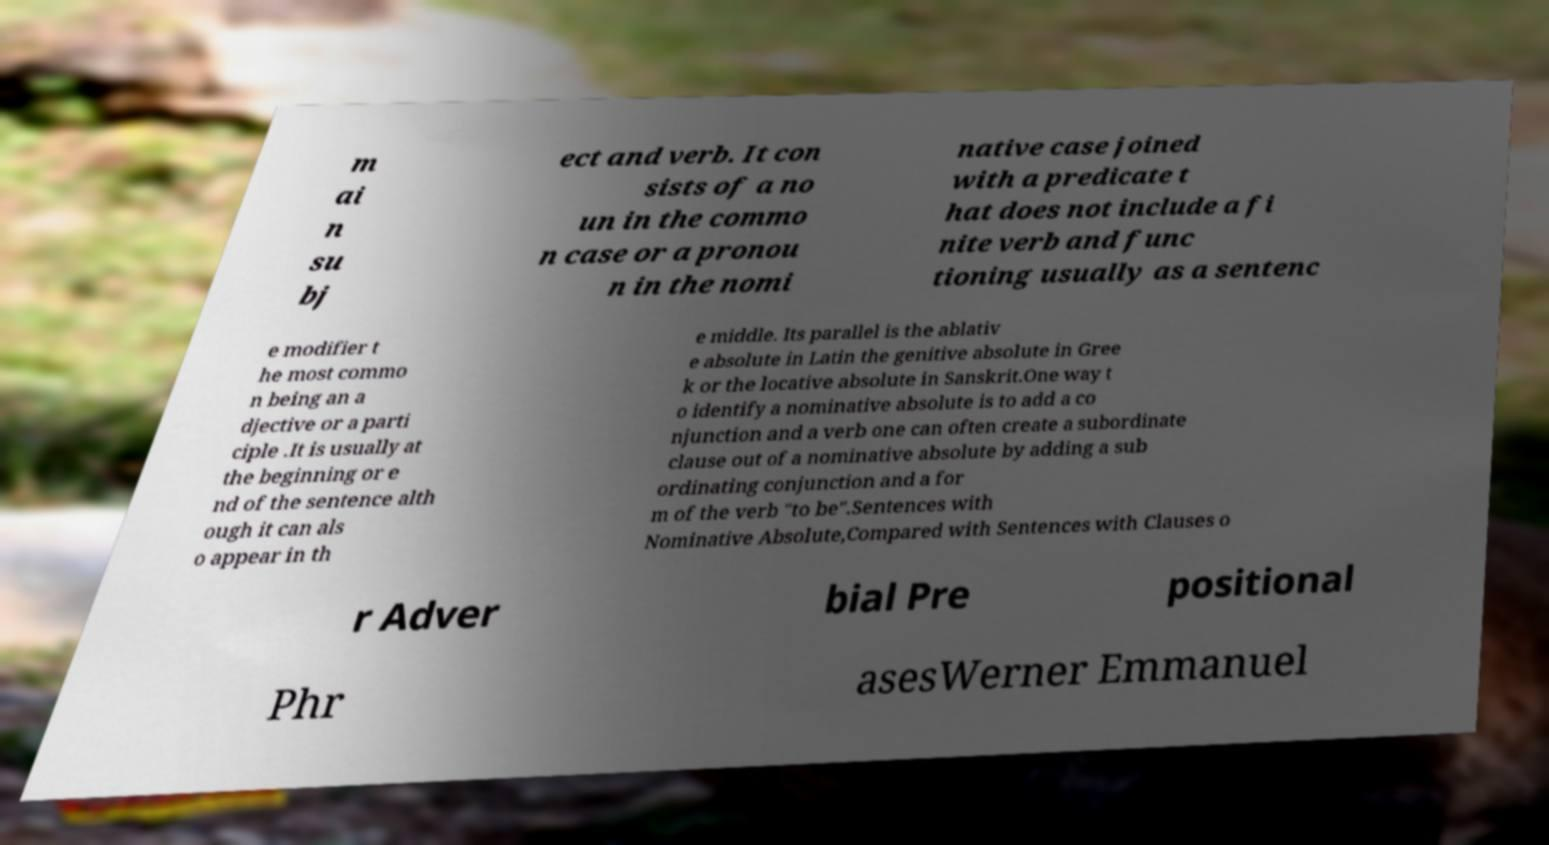There's text embedded in this image that I need extracted. Can you transcribe it verbatim? m ai n su bj ect and verb. It con sists of a no un in the commo n case or a pronou n in the nomi native case joined with a predicate t hat does not include a fi nite verb and func tioning usually as a sentenc e modifier t he most commo n being an a djective or a parti ciple .It is usually at the beginning or e nd of the sentence alth ough it can als o appear in th e middle. Its parallel is the ablativ e absolute in Latin the genitive absolute in Gree k or the locative absolute in Sanskrit.One way t o identify a nominative absolute is to add a co njunction and a verb one can often create a subordinate clause out of a nominative absolute by adding a sub ordinating conjunction and a for m of the verb "to be".Sentences with Nominative Absolute,Compared with Sentences with Clauses o r Adver bial Pre positional Phr asesWerner Emmanuel 